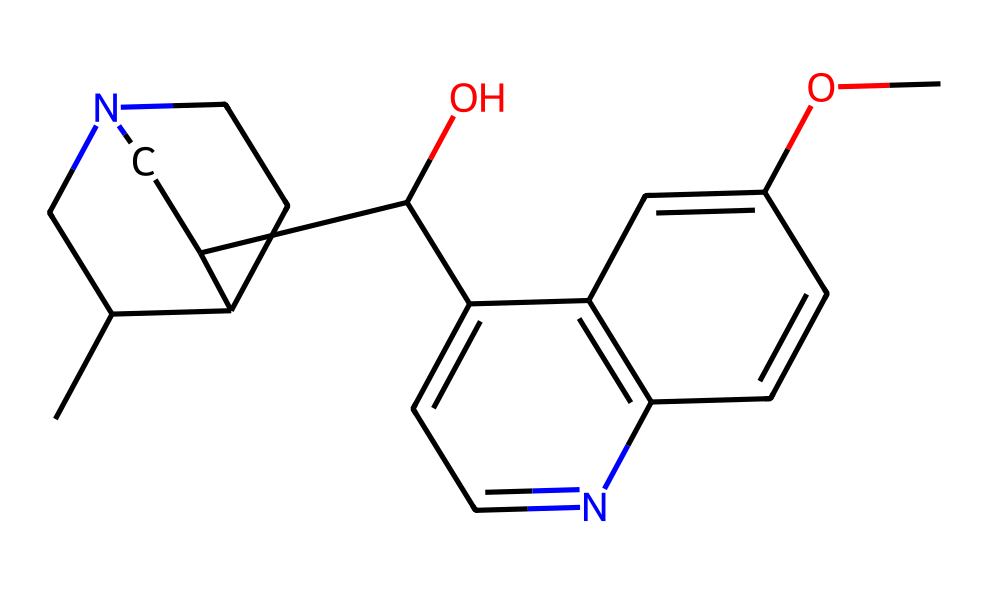What is the main functional group present in quinine? The most prominent functional group in quinine is the hydroxyl group (-OH) indicated by the presence of oxygen and hydrogen atoms connected to a carbon atom.
Answer: hydroxyl group How many nitrogen atoms are present in the chemical structure of quinine? By analyzing the SMILES representation, we can count the number of nitrogen atoms denoted by the letter 'N': there are two nitrogen atoms in the structure.
Answer: two What is the molecular formula of quinine? To derive the molecular formula, we can calculate the total number of each type of atom from the SMILES representation. For quinine, the molecular formula is C20H24N2O2.
Answer: C20H24N2O2 Which type of stereochemistry can quinine exhibit based on its structure? The presence of chiral centers in its cyclic structure indicates that quinine can exhibit optical isomerism, as these centers can create non-superimposable mirror images.
Answer: optical isomerism How many rings are present in the structure of quinine? By examining the structure carefully, we can identify three distinct cyclic structures in the chemical framework of quinine.
Answer: three rings What is the presence of an ether functional group in quinine's structure? The structure of quinine contains a methoxy group (-OCH3), which signifies the presence of an ether functional group, characterized by an oxygen atom bonded to two carbon-containing substituents.
Answer: yes 